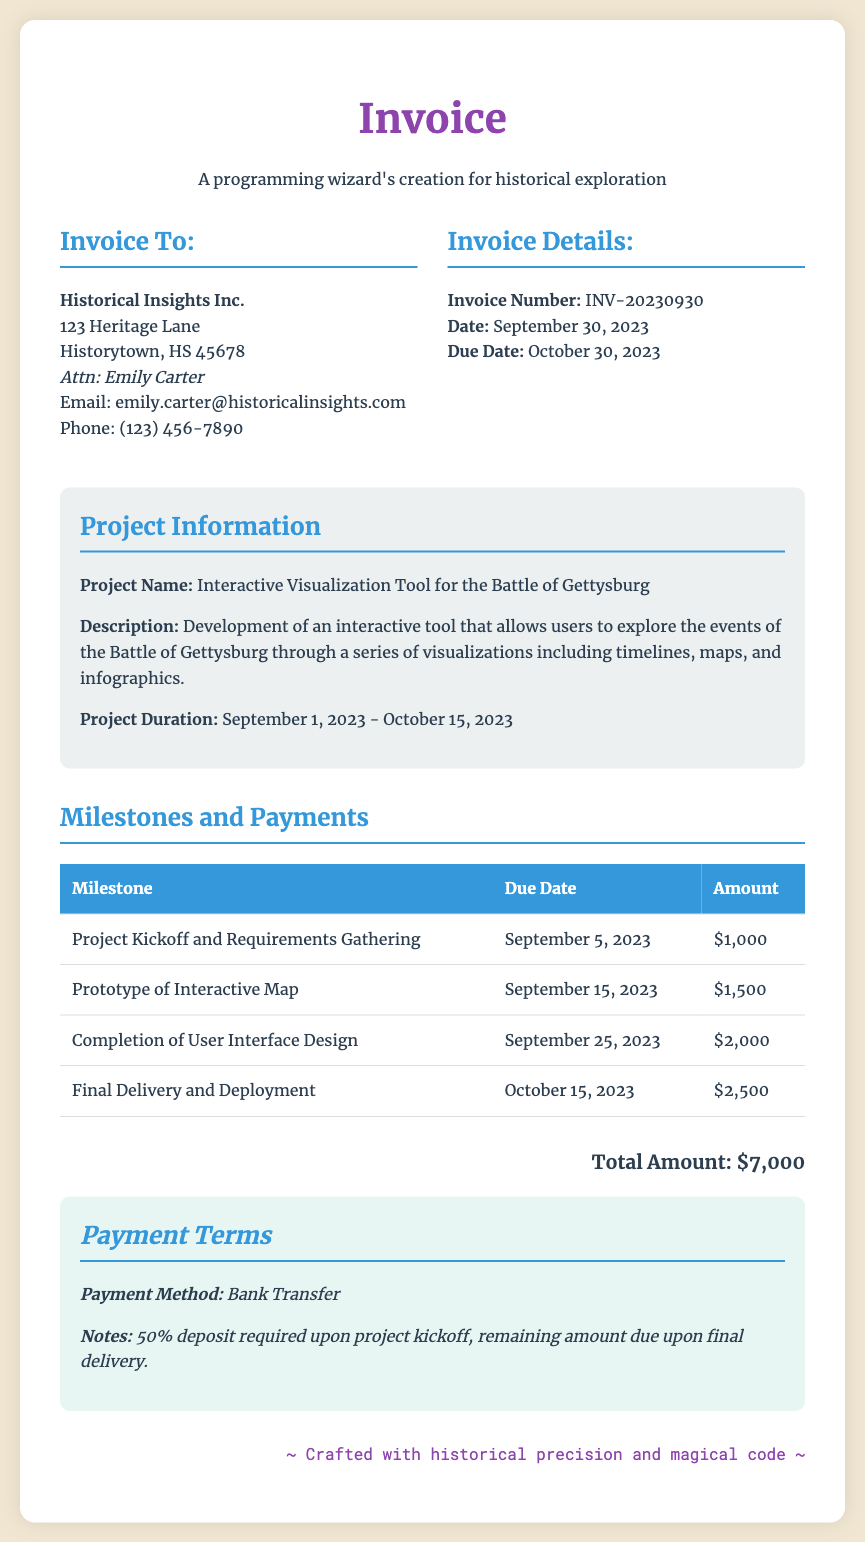What is the project name? The project name is stated in the document under the Project Information section, which is "Interactive Visualization Tool for the Battle of Gettysburg."
Answer: Interactive Visualization Tool for the Battle of Gettysburg What is the total amount due? The total amount is calculated from the milestones section and mentioned at the bottom of the document.
Answer: $7,000 Who is the invoice addressed to? The invoice is addressed to "Historical Insights Inc." which is listed in the Invoice To section.
Answer: Historical Insights Inc What is the due date of the invoice? The due date is provided in the Invoice Details section, indicating when the payment is expected.
Answer: October 30, 2023 How many milestones are listed in the document? The milestones are listed under the Milestones and Payments section, totaling four milestones.
Answer: 4 What percentage is required as a deposit? The document states the payment terms, including a deposit requirement which is clarified to be 50%.
Answer: 50% When is the final delivery date? The final delivery date of the project is specified under the milestones, indicating when the project will be completed.
Answer: October 15, 2023 What payment method is specified? The document specifies the method of payment clearly under the Payment Terms section.
Answer: Bank Transfer What is the contact person's name? The contact person's name is noted in the Invoice To section, specifying whom to reach out for inquiries.
Answer: Emily Carter 